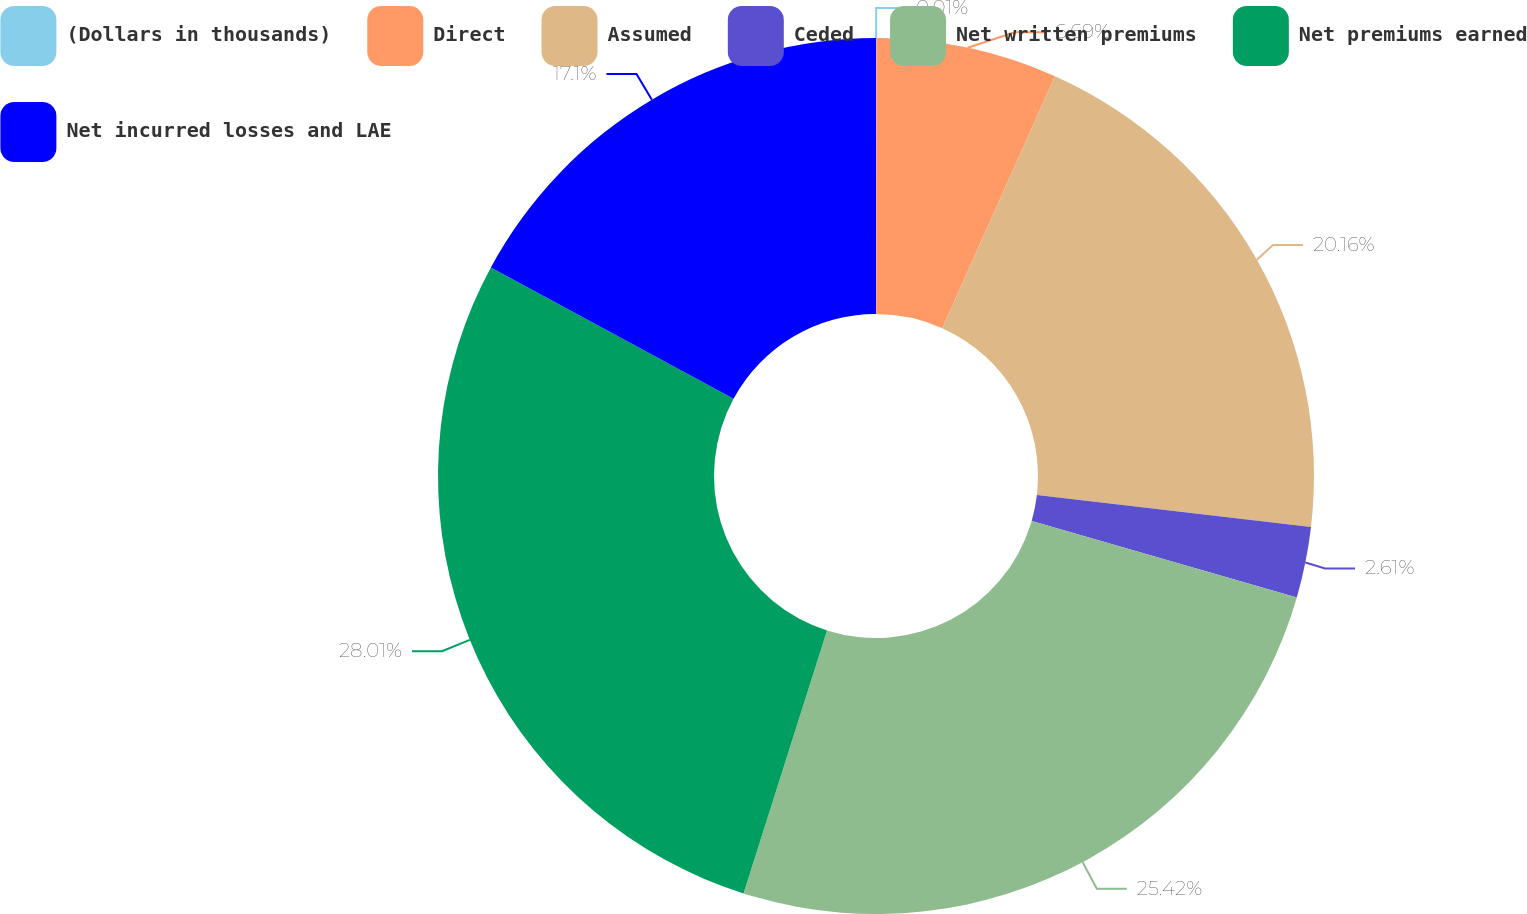<chart> <loc_0><loc_0><loc_500><loc_500><pie_chart><fcel>(Dollars in thousands)<fcel>Direct<fcel>Assumed<fcel>Ceded<fcel>Net written premiums<fcel>Net premiums earned<fcel>Net incurred losses and LAE<nl><fcel>0.01%<fcel>6.69%<fcel>20.16%<fcel>2.61%<fcel>25.42%<fcel>28.01%<fcel>17.1%<nl></chart> 